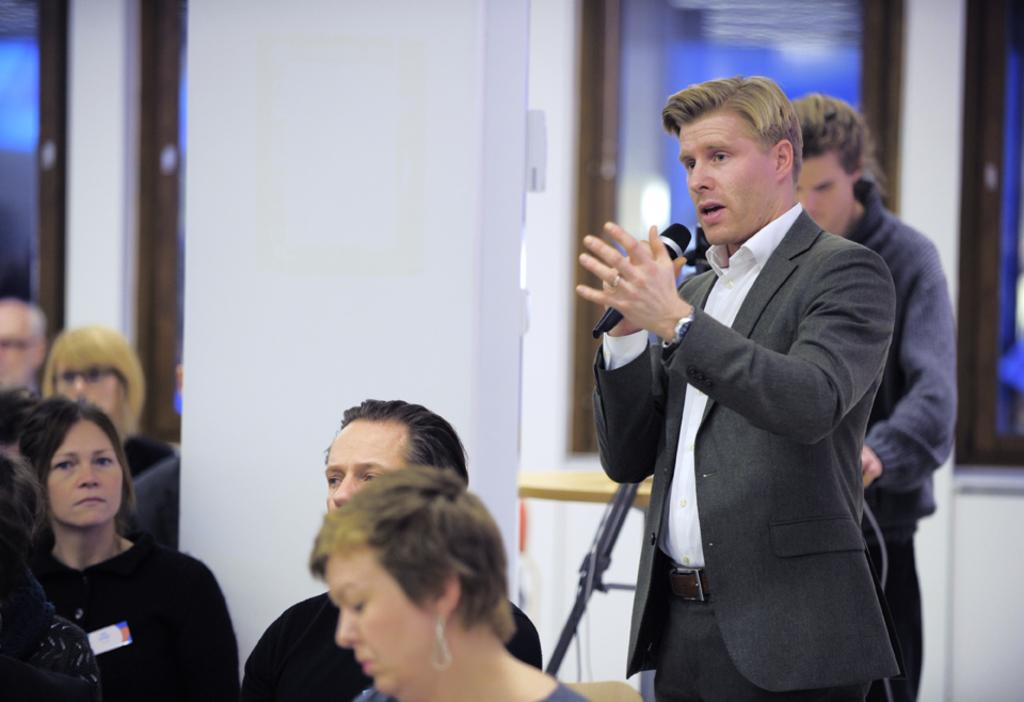What is the person in the image wearing? The person in the image is wearing a black suit. What is the person holding in the image? The person is holding a microphone. What are the other people in the image doing? The other people are sitting in front of the person with the microphone. Can you describe the man visible behind the person with the microphone? There is another man visible behind the person with the microphone, but no specific details about him are provided. What scent can be detected from the person wearing the black suit in the image? There is no information about the scent of the person wearing the black suit in the image. --- Facts: 1. There is a car in the image. 2. The car is red. 3. The car has four wheels. 4. There is a person sitting in the driver's seat. 5. The car is parked on the side of the road. Absurd Topics: dance, ocean, birdhouse Conversation: What type of vehicle is in the image? There is a car in the image. What color is the car? The car is red. How many wheels does the car have? The car has four wheels. Who is inside the car? There is a person sitting in the driver's seat. Where is the car located in the image? The car is parked on the side of the road. Reasoning: Let's think step by step in order to produce the conversation. We start by identifying the main subject in the image, which is the car. Then, we describe the car's color and the number of wheels it has. Next, we mention the presence of a person inside the car, specifically in the driver's seat. Finally, we describe the car's location in the image, which is parked on the side of the road. Absurd Question/Answer: Can you see any birdhouses in the image? There is no mention of a birdhouse in the image. 